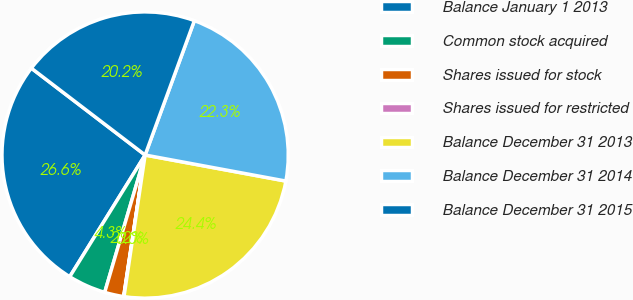<chart> <loc_0><loc_0><loc_500><loc_500><pie_chart><fcel>Balance January 1 2013<fcel>Common stock acquired<fcel>Shares issued for stock<fcel>Shares issued for restricted<fcel>Balance December 31 2013<fcel>Balance December 31 2014<fcel>Balance December 31 2015<nl><fcel>26.55%<fcel>4.27%<fcel>2.16%<fcel>0.04%<fcel>24.44%<fcel>22.32%<fcel>20.21%<nl></chart> 